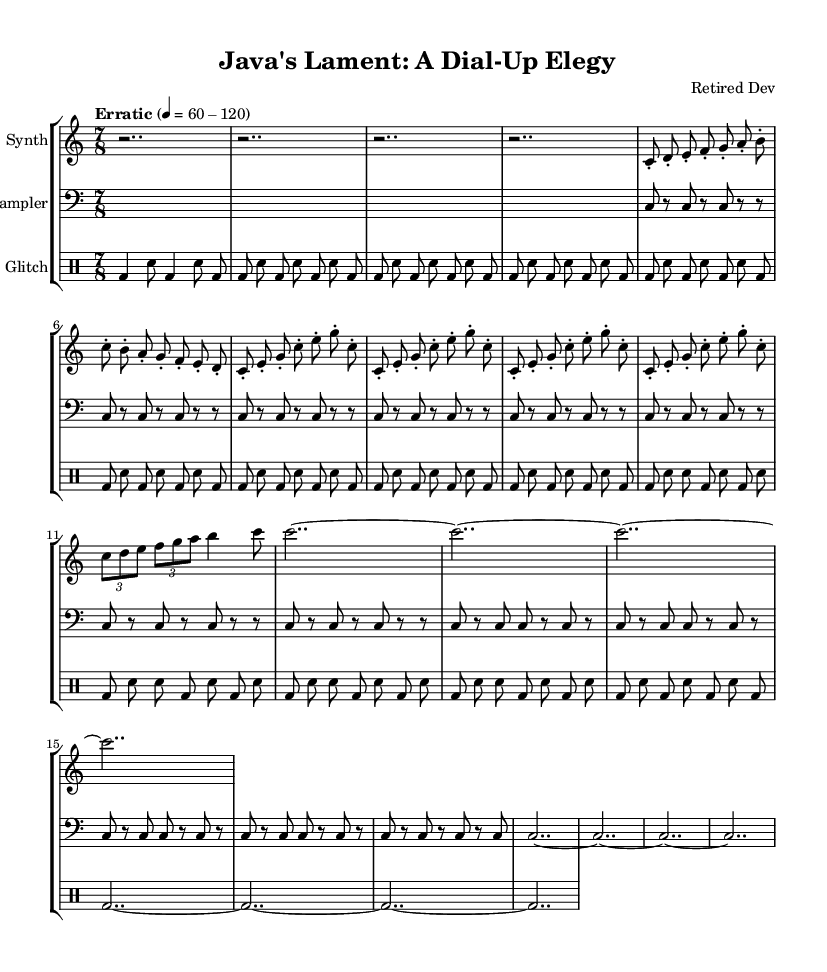What is the time signature of this music? The time signature is indicated at the beginning of the score as 7/8, which means there are seven beats in each measure and the eighth note receives one beat.
Answer: 7/8 What is the tempo marking of the piece? The tempo marking found in the global section of the score is "Erratic," and it suggests a variable tempo that can range from 60 to 120 beats per minute.
Answer: Erratic How many measures are there in the chorus section? The chorus comprises four repetitions of a specific eight-note sequence, each structure consists of the same notes, confirming that there are four measures dedicated to the chorus.
Answer: 4 What is the primary instrument used for the melody? The synthesizer part, indicated at the beginning of the score, primarily carries the melodic elements, differentiated from the sampler and percussion sections.
Answer: Synthesizer How many times does the verse section repeat? The verse section is indicated to repeat a total of eight times throughout the piece, allowing for variation and development of the melodic motif presented initially.
Answer: 8 What type of percussion is primarily used in this composition? The percussion part is marked as "bd" representing bass drum and "sn" which signifies snare drum, these are typical for creating rhythmic patterns in glitch music.
Answer: Bass drum and snare drum 